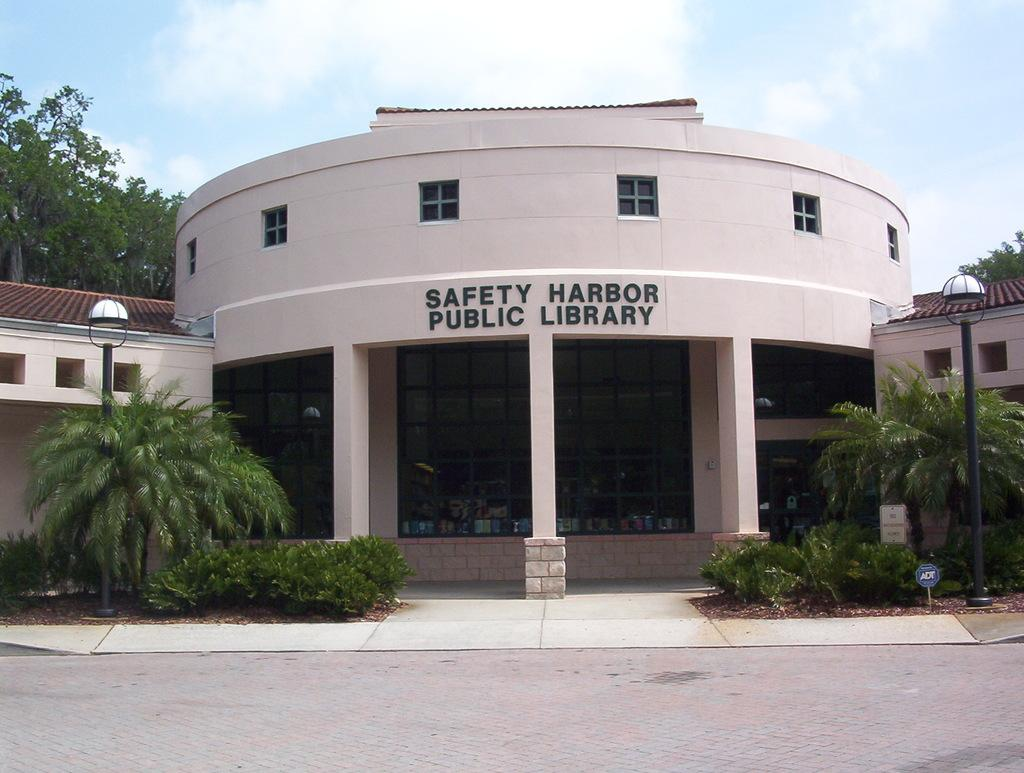What type of surface is visible in the image? There is a pavement in the image. What can be seen in the background of the image? There are plants, trees, light poles, buildings, and the sky visible in the background of the image. What type of lace is used to decorate the sweater in the image? There is no sweater or lace present in the image. How many oranges are visible on the pavement in the image? There are no oranges visible on the pavement in the image. 